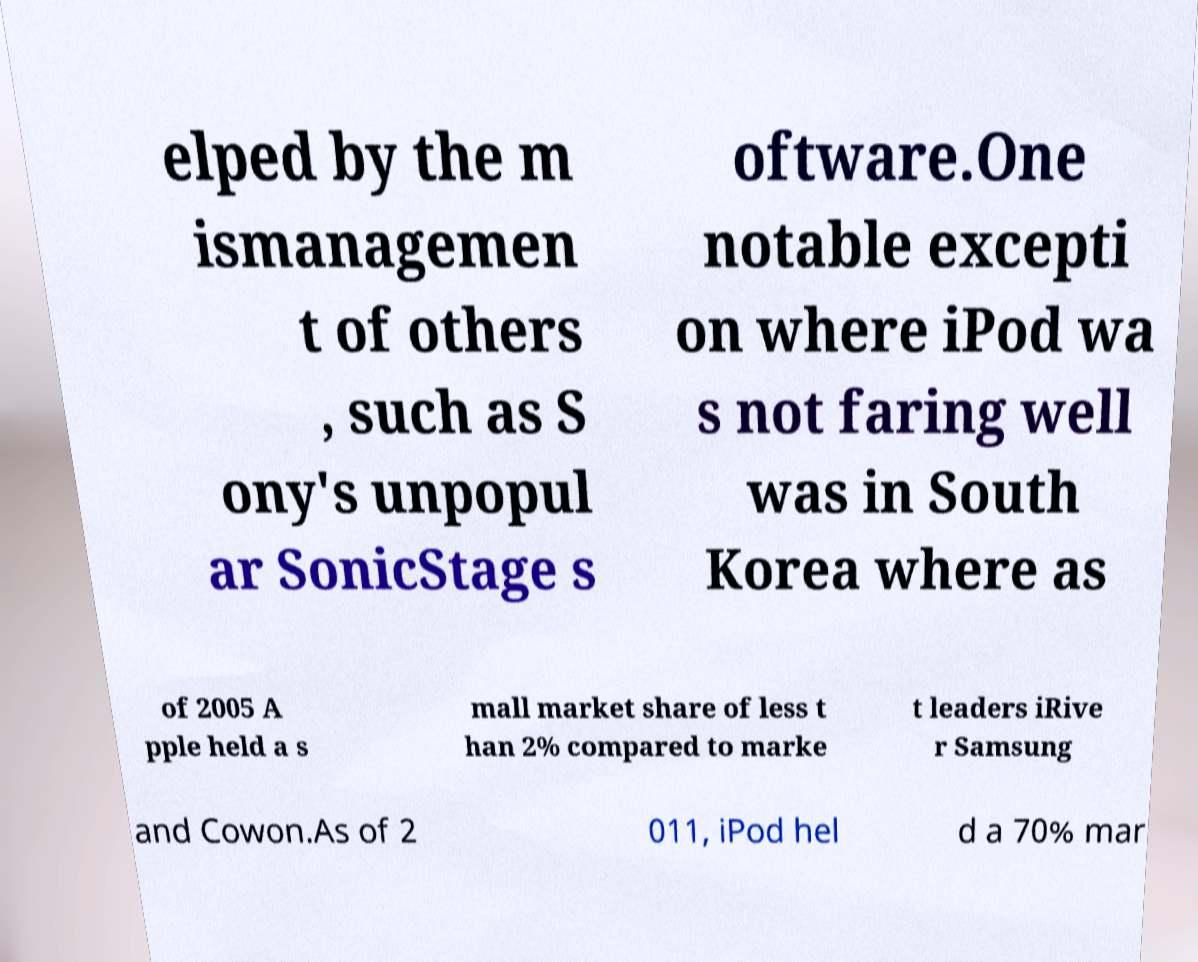What messages or text are displayed in this image? I need them in a readable, typed format. elped by the m ismanagemen t of others , such as S ony's unpopul ar SonicStage s oftware.One notable excepti on where iPod wa s not faring well was in South Korea where as of 2005 A pple held a s mall market share of less t han 2% compared to marke t leaders iRive r Samsung and Cowon.As of 2 011, iPod hel d a 70% mar 